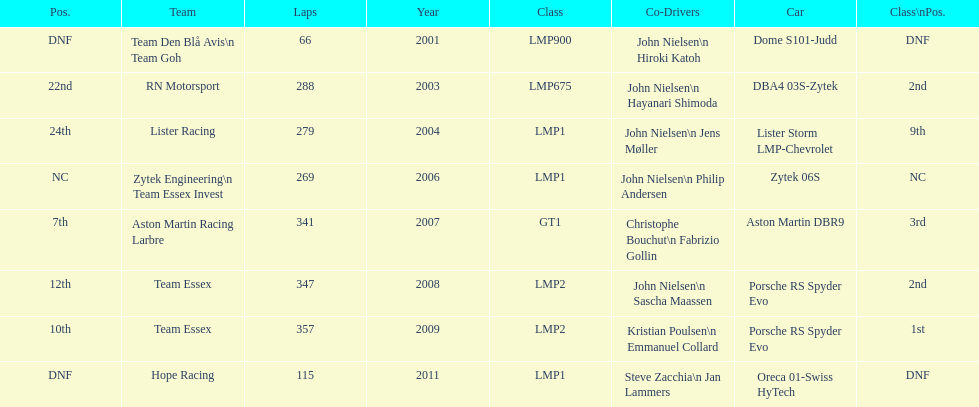In 2008 and what other year was casper elgaard on team essex for the 24 hours of le mans? 2009. 